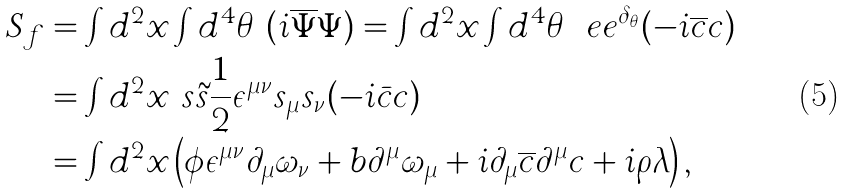<formula> <loc_0><loc_0><loc_500><loc_500>S _ { f } & = \int d ^ { 2 } x \int d ^ { 4 } \theta \ ( i \overline { \Psi } \Psi ) = \int d ^ { 2 } x \int d ^ { 4 } \theta \ \ e e ^ { \delta _ { \theta } } ( - i \overline { c } c ) \\ & = \int d ^ { 2 } x \ s \tilde { s } \frac { 1 } { 2 } \epsilon ^ { \mu \nu } s _ { \mu } s _ { \nu } ( - i \bar { c } c ) \\ & = \int d ^ { 2 } x \left ( \phi \epsilon ^ { \mu \nu } \partial _ { \mu } \omega _ { \nu } + b \partial ^ { \mu } \omega _ { \mu } + i \partial _ { \mu } \overline { c } \partial ^ { \mu } c + i \rho \lambda \right ) ,</formula> 